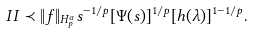<formula> <loc_0><loc_0><loc_500><loc_500>I I \prec \| f \| _ { H ^ { \alpha } _ { p } } s ^ { - 1 / p } [ \Psi ( s ) ] ^ { 1 / p } [ h ( \lambda ) ] ^ { 1 - 1 / p } .</formula> 